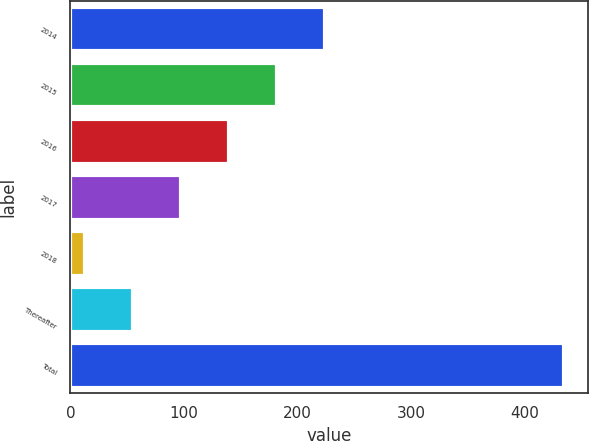<chart> <loc_0><loc_0><loc_500><loc_500><bar_chart><fcel>2014<fcel>2015<fcel>2016<fcel>2017<fcel>2018<fcel>Thereafter<fcel>Total<nl><fcel>223.8<fcel>181.7<fcel>139.6<fcel>97.5<fcel>13.3<fcel>55.4<fcel>434.3<nl></chart> 